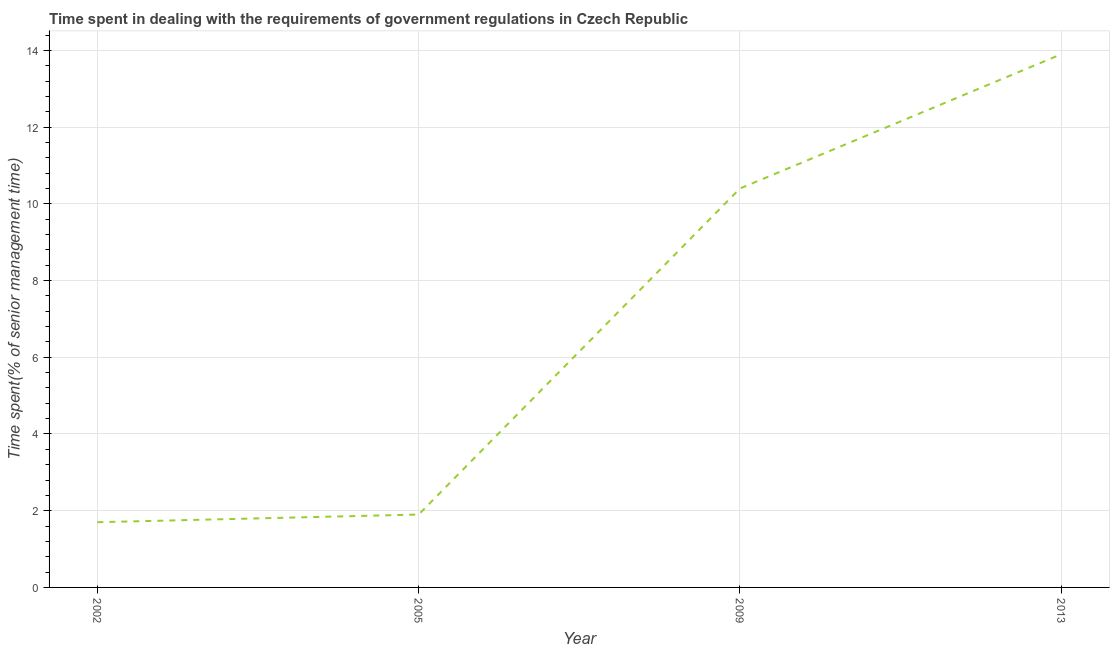Across all years, what is the maximum time spent in dealing with government regulations?
Provide a succinct answer. 13.9. In which year was the time spent in dealing with government regulations maximum?
Provide a succinct answer. 2013. In which year was the time spent in dealing with government regulations minimum?
Provide a succinct answer. 2002. What is the sum of the time spent in dealing with government regulations?
Give a very brief answer. 27.9. What is the difference between the time spent in dealing with government regulations in 2002 and 2013?
Your answer should be compact. -12.2. What is the average time spent in dealing with government regulations per year?
Keep it short and to the point. 6.97. What is the median time spent in dealing with government regulations?
Your answer should be compact. 6.15. In how many years, is the time spent in dealing with government regulations greater than 2 %?
Provide a succinct answer. 2. What is the ratio of the time spent in dealing with government regulations in 2002 to that in 2009?
Provide a succinct answer. 0.16. Is the difference between the time spent in dealing with government regulations in 2005 and 2009 greater than the difference between any two years?
Offer a very short reply. No. What is the difference between the highest and the second highest time spent in dealing with government regulations?
Provide a short and direct response. 3.5. What is the difference between the highest and the lowest time spent in dealing with government regulations?
Your response must be concise. 12.2. In how many years, is the time spent in dealing with government regulations greater than the average time spent in dealing with government regulations taken over all years?
Give a very brief answer. 2. What is the difference between two consecutive major ticks on the Y-axis?
Provide a short and direct response. 2. Are the values on the major ticks of Y-axis written in scientific E-notation?
Keep it short and to the point. No. Does the graph contain any zero values?
Give a very brief answer. No. Does the graph contain grids?
Keep it short and to the point. Yes. What is the title of the graph?
Provide a succinct answer. Time spent in dealing with the requirements of government regulations in Czech Republic. What is the label or title of the Y-axis?
Ensure brevity in your answer.  Time spent(% of senior management time). What is the Time spent(% of senior management time) of 2005?
Keep it short and to the point. 1.9. What is the Time spent(% of senior management time) in 2009?
Provide a succinct answer. 10.4. What is the Time spent(% of senior management time) of 2013?
Provide a short and direct response. 13.9. What is the difference between the Time spent(% of senior management time) in 2002 and 2005?
Provide a succinct answer. -0.2. What is the difference between the Time spent(% of senior management time) in 2002 and 2009?
Your response must be concise. -8.7. What is the difference between the Time spent(% of senior management time) in 2002 and 2013?
Your answer should be compact. -12.2. What is the difference between the Time spent(% of senior management time) in 2005 and 2009?
Give a very brief answer. -8.5. What is the difference between the Time spent(% of senior management time) in 2005 and 2013?
Make the answer very short. -12. What is the difference between the Time spent(% of senior management time) in 2009 and 2013?
Your answer should be compact. -3.5. What is the ratio of the Time spent(% of senior management time) in 2002 to that in 2005?
Offer a very short reply. 0.9. What is the ratio of the Time spent(% of senior management time) in 2002 to that in 2009?
Offer a terse response. 0.16. What is the ratio of the Time spent(% of senior management time) in 2002 to that in 2013?
Offer a very short reply. 0.12. What is the ratio of the Time spent(% of senior management time) in 2005 to that in 2009?
Your response must be concise. 0.18. What is the ratio of the Time spent(% of senior management time) in 2005 to that in 2013?
Your answer should be very brief. 0.14. What is the ratio of the Time spent(% of senior management time) in 2009 to that in 2013?
Provide a succinct answer. 0.75. 